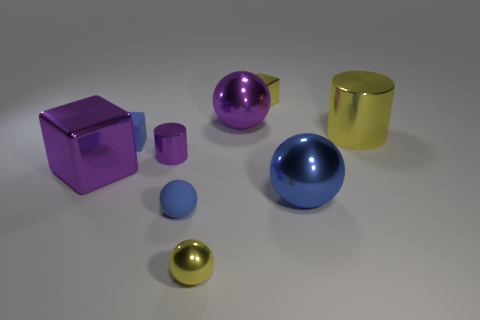Can you describe the different materials and shapes present in this image? Certainly! In this image, there are objects made of metal and rubber. The shapes include a sphere, a cube, and a cylinder. Specifically, there's a purple metal cube, a blue rubber sphere, a yellow metal cylinder, and smaller objects of similar materials and shapes. 